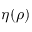Convert formula to latex. <formula><loc_0><loc_0><loc_500><loc_500>\eta ( \rho )</formula> 